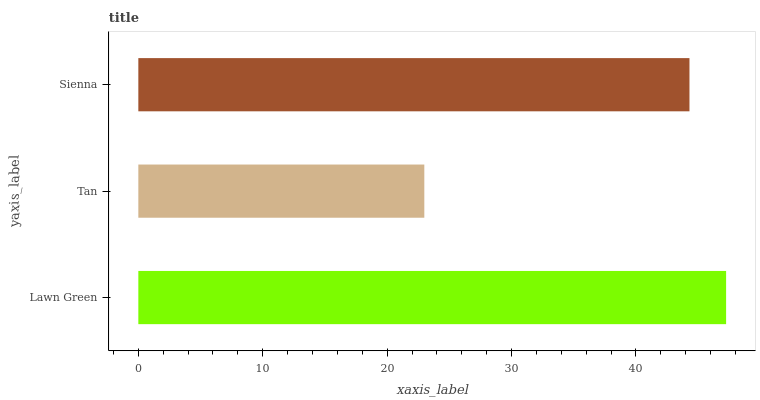Is Tan the minimum?
Answer yes or no. Yes. Is Lawn Green the maximum?
Answer yes or no. Yes. Is Sienna the minimum?
Answer yes or no. No. Is Sienna the maximum?
Answer yes or no. No. Is Sienna greater than Tan?
Answer yes or no. Yes. Is Tan less than Sienna?
Answer yes or no. Yes. Is Tan greater than Sienna?
Answer yes or no. No. Is Sienna less than Tan?
Answer yes or no. No. Is Sienna the high median?
Answer yes or no. Yes. Is Sienna the low median?
Answer yes or no. Yes. Is Lawn Green the high median?
Answer yes or no. No. Is Lawn Green the low median?
Answer yes or no. No. 